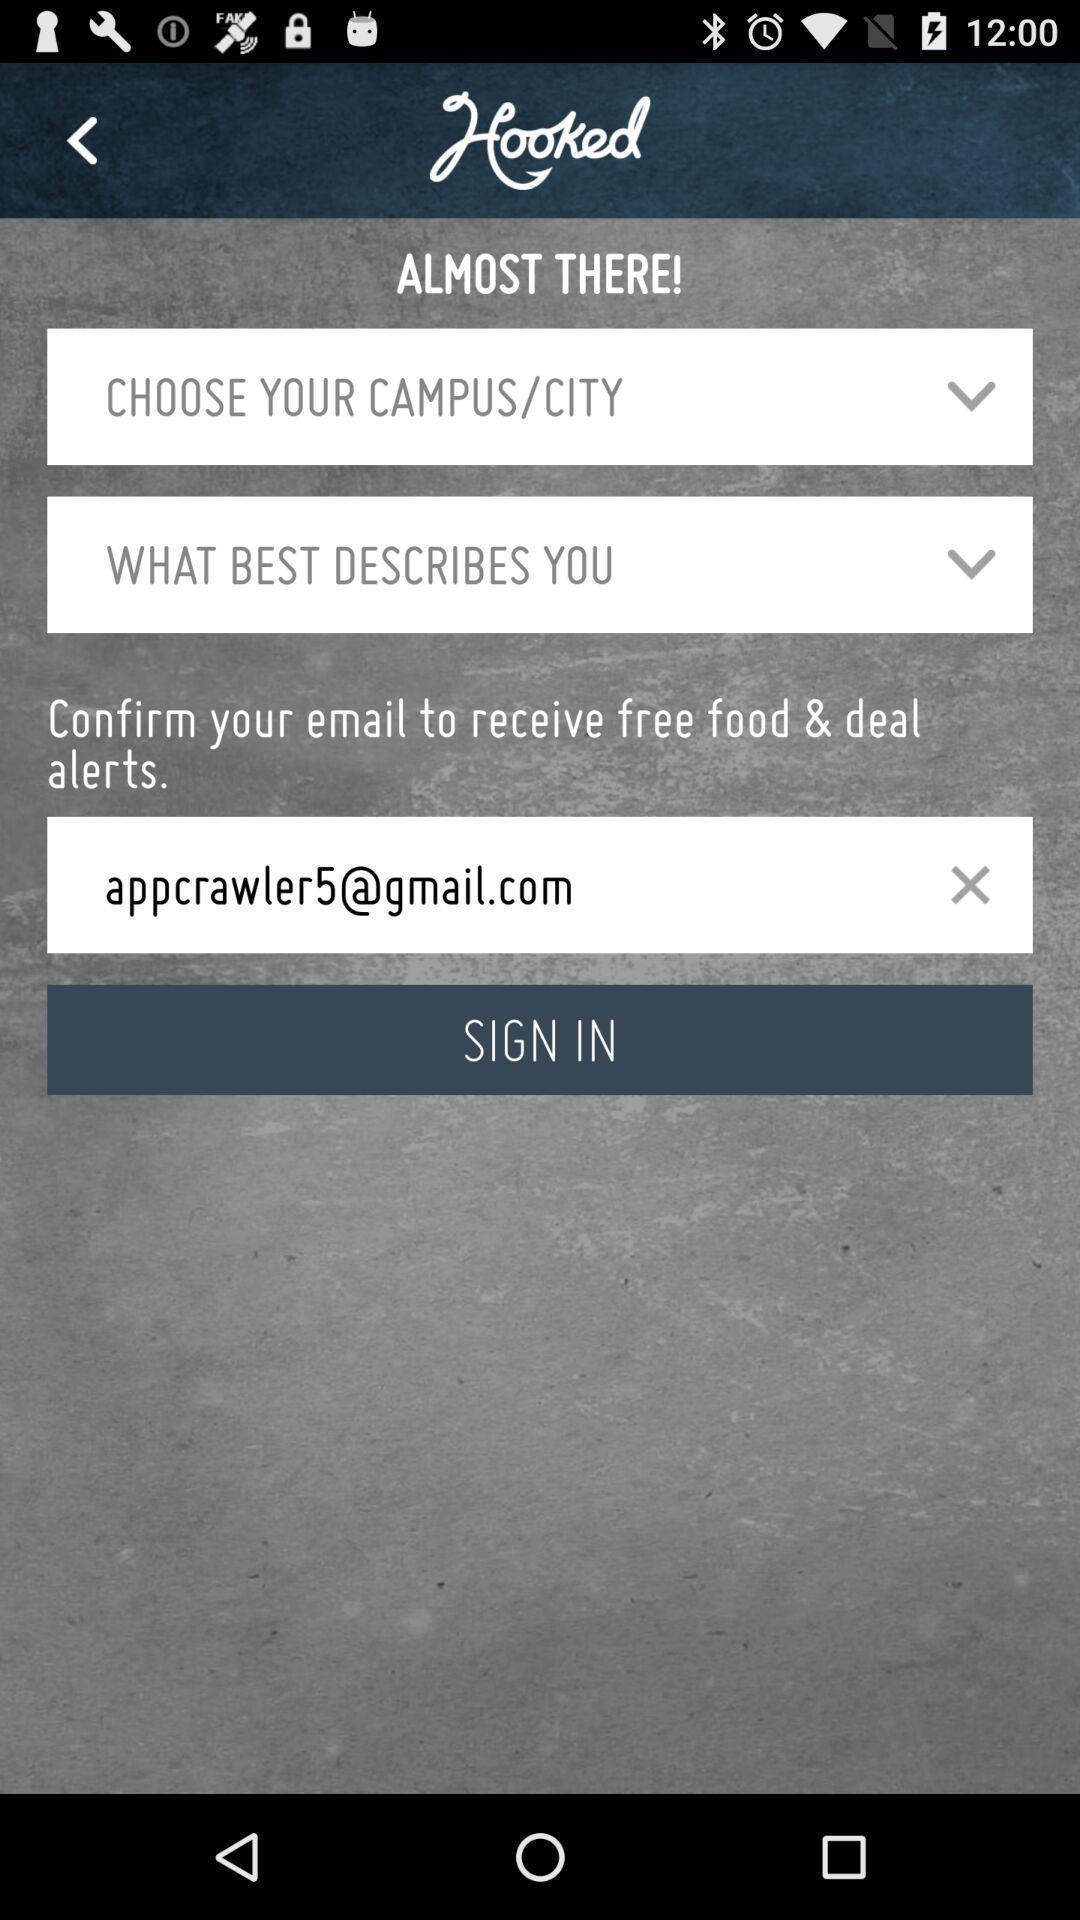Describe the content in this image. Sign in page. 